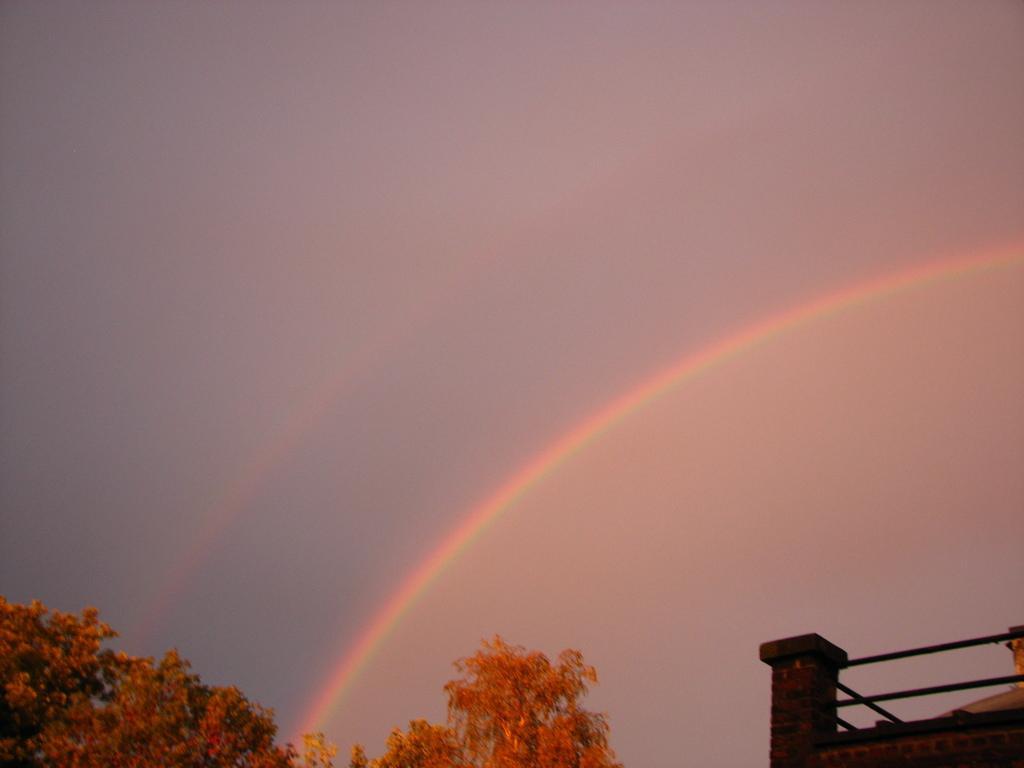Please provide a concise description of this image. In this image there is a rainbow in the sky under that there is a tree and building. 